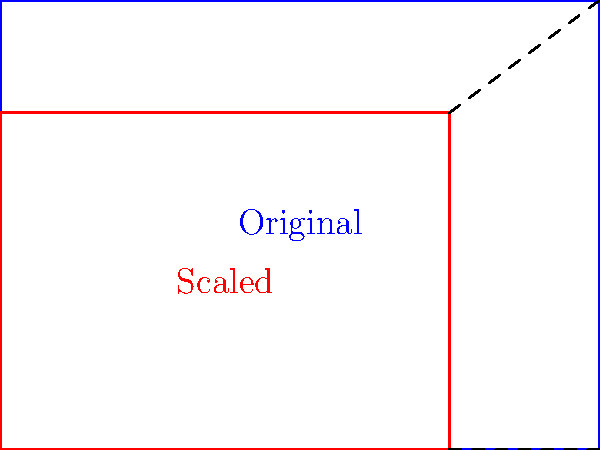Due to relocation after flooding, a family needs to scale down their furniture to fit a smaller living space. Their rectangular dining table measures 8 feet by 6 feet. If they need to reduce the area of the table by 25% while maintaining its proportions, what will be the dimensions of the new table? Let's approach this step-by-step:

1) First, let's calculate the current area of the table:
   $A_1 = 8 \text{ ft} \times 6 \text{ ft} = 48 \text{ sq ft}$

2) We need to reduce this area by 25%, so the new area will be:
   $A_2 = 48 \text{ sq ft} \times (1 - 0.25) = 48 \text{ sq ft} \times 0.75 = 36 \text{ sq ft}$

3) To maintain proportions, we need to scale both dimensions by the same factor. Let's call this factor $k$. 
   If we scale both dimensions by $k$, the new area will be $k^2$ times the original area.

4) We can set up the equation:
   $k^2 \times 48 \text{ sq ft} = 36 \text{ sq ft}$

5) Solving for $k$:
   $k^2 = \frac{36}{48} = 0.75$
   $k = \sqrt{0.75} \approx 0.866$

6) Now we can calculate the new dimensions:
   New length = $8 \text{ ft} \times 0.866 = 6.928 \text{ ft} \approx 6.93 \text{ ft}$
   New width = $6 \text{ ft} \times 0.866 = 5.196 \text{ ft} \approx 5.20 \text{ ft}$

Therefore, the new dimensions of the table will be approximately 6.93 feet by 5.20 feet.
Answer: $6.93 \text{ ft} \times 5.20 \text{ ft}$ 